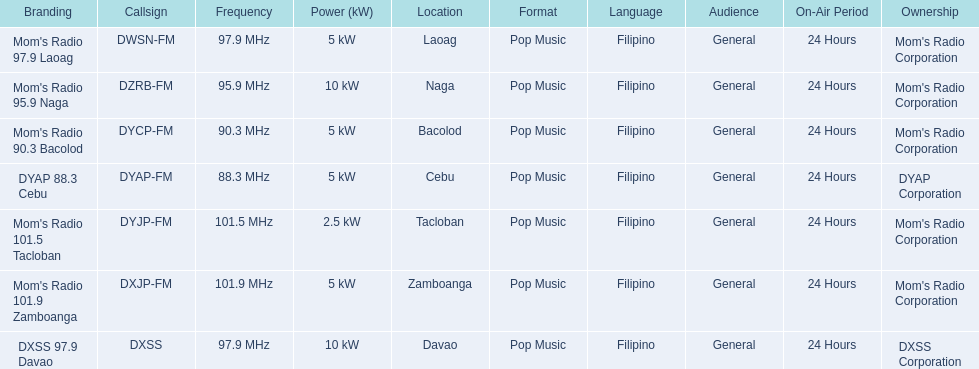Which stations broadcast in dyap-fm? Mom's Radio 97.9 Laoag, Mom's Radio 95.9 Naga, Mom's Radio 90.3 Bacolod, DYAP 88.3 Cebu, Mom's Radio 101.5 Tacloban, Mom's Radio 101.9 Zamboanga, DXSS 97.9 Davao. Of those stations which broadcast in dyap-fm, which stations broadcast with 5kw of power or under? Mom's Radio 97.9 Laoag, Mom's Radio 90.3 Bacolod, DYAP 88.3 Cebu, Mom's Radio 101.5 Tacloban, Mom's Radio 101.9 Zamboanga. Of those stations that broadcast with 5kw of power or under, which broadcasts with the least power? Mom's Radio 101.5 Tacloban. 